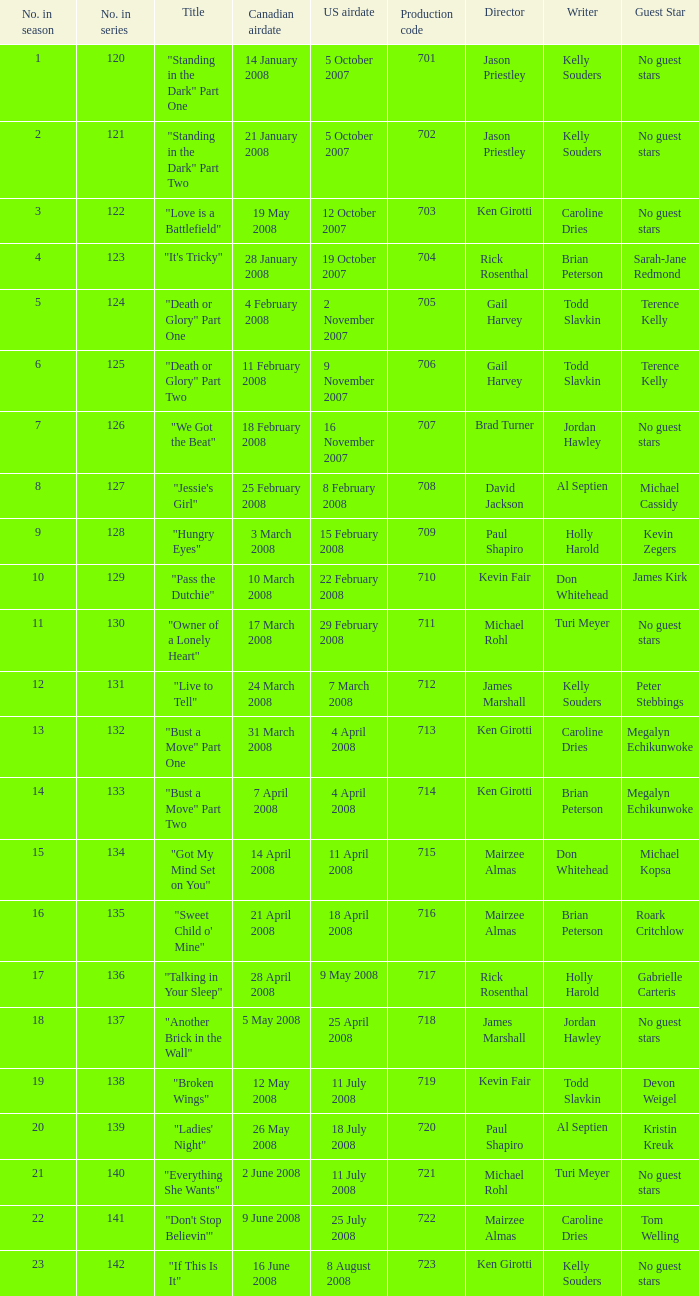The U.S. airdate of 8 august 2008 also had canadian airdates of what? 16 June 2008. 